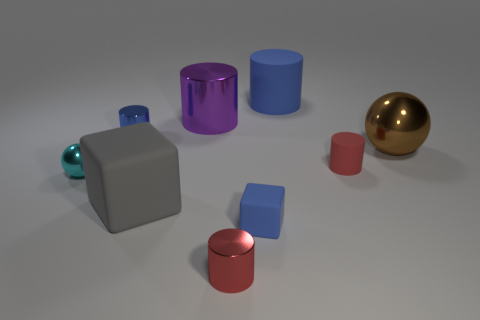There is a cube that is the same color as the large matte cylinder; what is its material?
Your answer should be compact. Rubber. Is there any other thing that is the same shape as the big gray thing?
Provide a succinct answer. Yes. How many things are either brown metallic spheres or large gray cubes?
Provide a succinct answer. 2. There is another blue shiny object that is the same shape as the large blue thing; what is its size?
Provide a short and direct response. Small. Is there anything else that is the same size as the blue matte cylinder?
Provide a succinct answer. Yes. How many other things are the same color as the tiny block?
Your answer should be very brief. 2. What number of cylinders are either red shiny objects or big brown objects?
Offer a terse response. 1. What is the color of the tiny matte object that is in front of the ball in front of the brown shiny object?
Your response must be concise. Blue. The red rubber object is what shape?
Give a very brief answer. Cylinder. Do the metallic ball that is left of the brown metal thing and the large purple shiny object have the same size?
Offer a very short reply. No. 